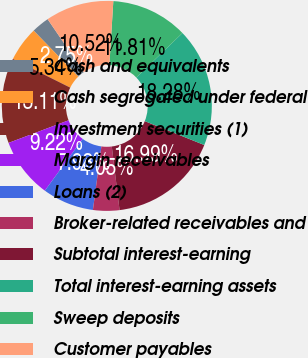Convert chart to OTSL. <chart><loc_0><loc_0><loc_500><loc_500><pie_chart><fcel>Cash and equivalents<fcel>Cash segregated under federal<fcel>Investment securities (1)<fcel>Margin receivables<fcel>Loans (2)<fcel>Broker-related receivables and<fcel>Subtotal interest-earning<fcel>Total interest-earning assets<fcel>Sweep deposits<fcel>Customer payables<nl><fcel>2.75%<fcel>5.34%<fcel>13.11%<fcel>9.22%<fcel>7.93%<fcel>4.05%<fcel>16.99%<fcel>18.28%<fcel>11.81%<fcel>10.52%<nl></chart> 